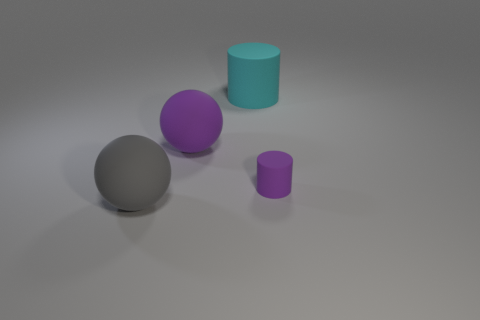Do the objects seem like they are randomly placed, or is there a pattern to their arrangement? Their placement appears deliberate, forming a diagonal line from the bottom left to the upper right of the image. This kind of arrangement can guide the viewer's eye across the scene, suggesting a thoughtful composition rather than randomness. 